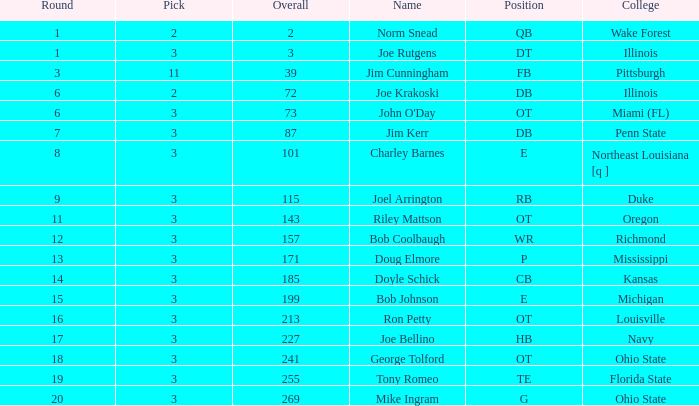How many overalls feature charley barnes as the name, with an option less than 3? None. 